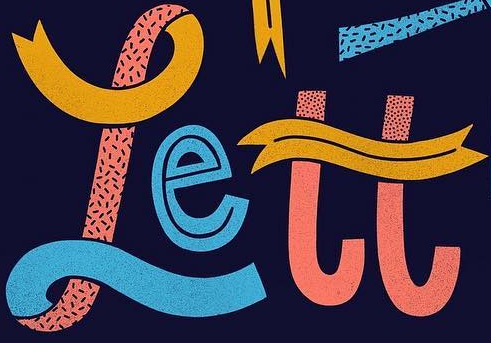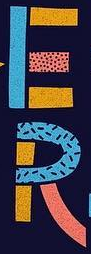Transcribe the words shown in these images in order, separated by a semicolon. rett; ER 